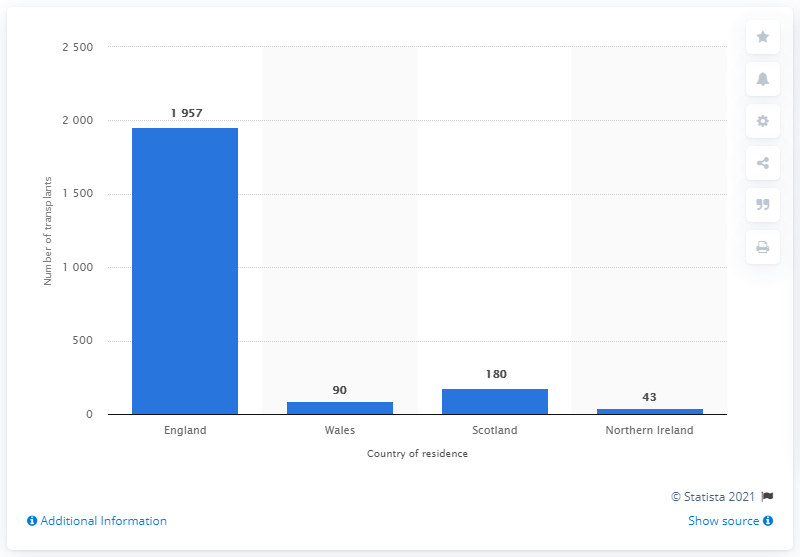Point out several critical features in this image. In the 2019/2020 fiscal year, 180 kidney transplants were performed in Scotland. 